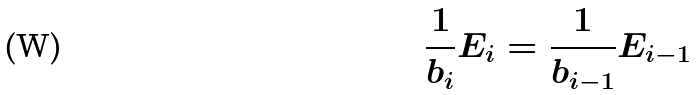Convert formula to latex. <formula><loc_0><loc_0><loc_500><loc_500>\frac { 1 } { b _ { i } } E _ { i } = \frac { 1 } { b _ { i - 1 } } E _ { i - 1 }</formula> 